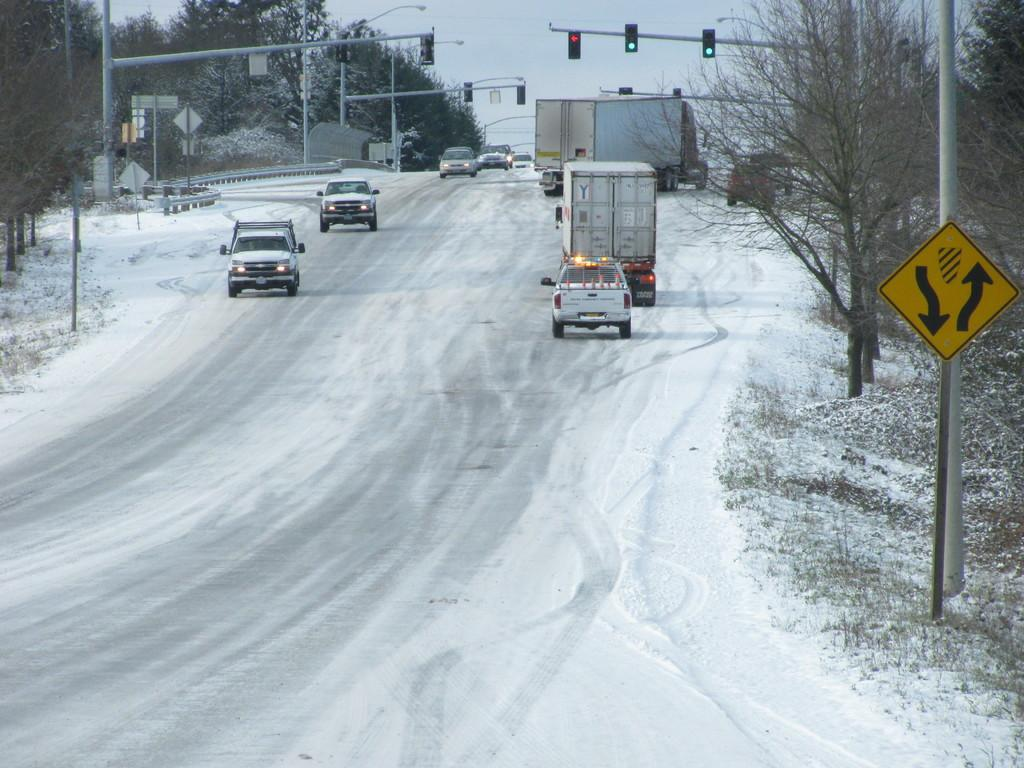What can be seen on the road in the image? There are cars parked on the road in the image. What is covering the ground in the image? The ground is covered with snow. What type of vegetation is visible in the image? There are trees visible in the image. What helps regulate traffic in the image? There are traffic signal poles in the image. What process is being carried out in the wilderness in the image? There is no wilderness present in the image, and no process is being carried out. Can you describe the blowing wind in the image? There is no mention of wind in the image, so it cannot be described. 